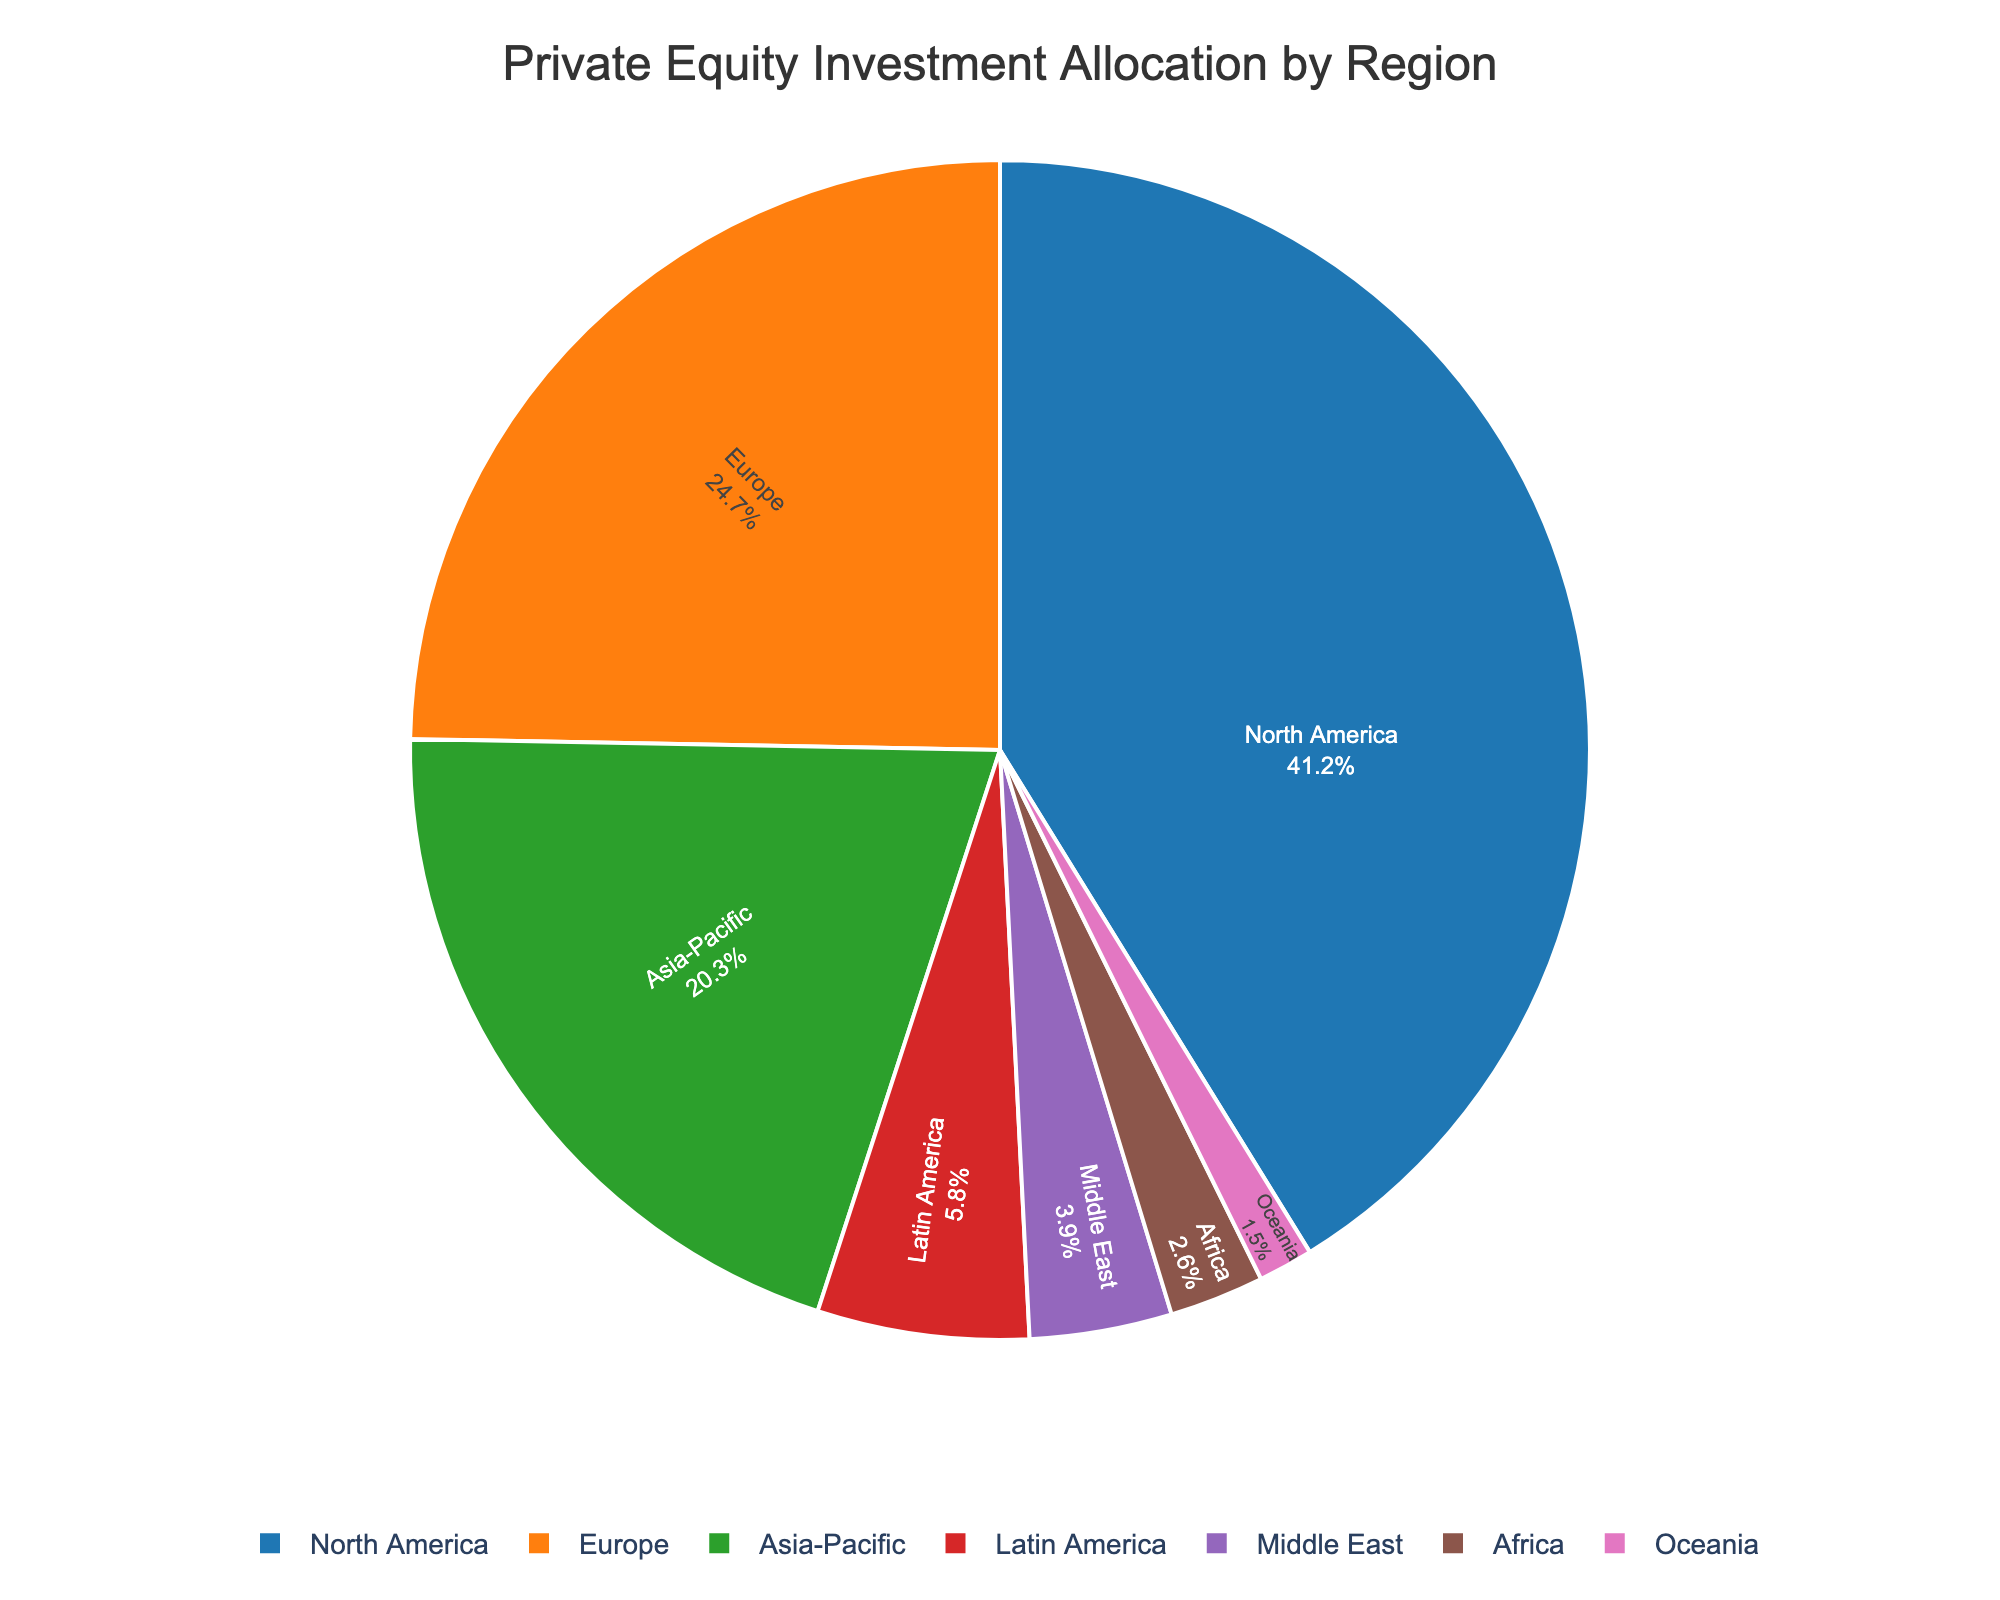What is the largest allocation of private equity investments by region? To find the largest allocation, look for the region with the highest percentage in the pie chart. North America has the highest allocation percentage at 41.2%.
Answer: 41.2% Which region has the second smallest allocation percentage? To answer this, identify the regions with allocation percentages and order them. The second smallest percentage is just above the smallest, which is Oceania at 1.5%, so the next one is Africa at 2.6%.
Answer: Africa How much greater is the allocation percentage of North America compared to Europe? North America's allocation is 41.2%, and Europe's allocation is 24.7%. The difference is 41.2% - 24.7% = 16.5%.
Answer: 16.5% Which regions have an allocation less than 10%? Check the pie chart for region slices that are under 10%. The regions are Latin America (5.8%), Middle East (3.9%), Africa (2.6%), and Oceania (1.5%).
Answer: Latin America, Middle East, Africa, Oceania What is the combined allocation percentage for Asia-Pacific and Europe? Sum the allocation percentages for Asia-Pacific (20.3%) and Europe (24.7%). The combined percentage is 20.3% + 24.7% = 45%.
Answer: 45% Which region is represented by the green color in the pie chart? Observe the pie chart and match the green color with the corresponding region. In this chart, the green color represents Asia-Pacific.
Answer: Asia-Pacific Are there more regions with an allocation above or below 5%? List the regions above and below 5% allocations, then count. Regions above 5%: North America, Europe, Asia-Pacific, Latin America. Regions below 5%: Middle East, Africa, Oceania. Both have 3 regions.
Answer: Equal number Rank the regions by their allocation percentages from highest to lowest. Array the regions from highest to lowest allocation. The order is: North America (41.2%), Europe (24.7%), Asia-Pacific (20.3%), Latin America (5.8%), Middle East (3.9%), Africa (2.6%), Oceania (1.5%).
Answer: North America, Europe, Asia-Pacific, Latin America, Middle East, Africa, Oceania What is the average allocation percentage for Latin America, Middle East, and Africa? Sum the percentages for Latin America (5.8%), Middle East (3.9%), and Africa (2.6%), then divide by 3. The average is (5.8% + 3.9% + 2.6%) / 3 = 4.1%.
Answer: 4.1% 